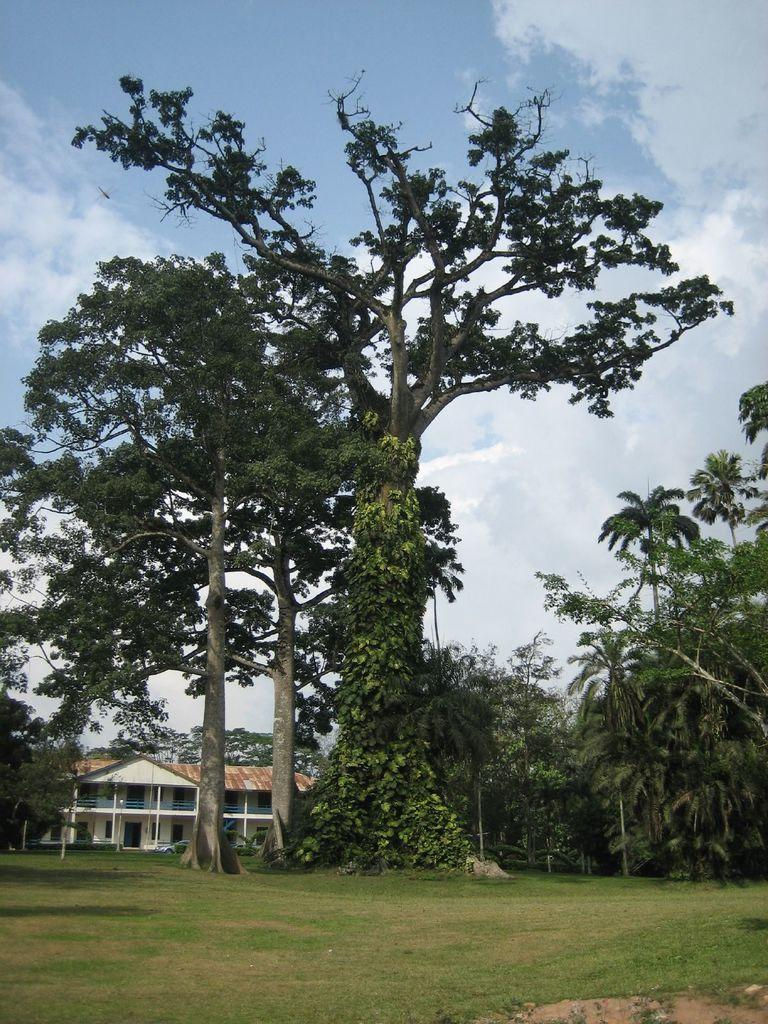What type of structure is present in the image? There is a building in the image. What feature can be observed on the building? The building has windows. What type of vegetation is present in the image? There are trees in the image. How would you describe the sky in the image? The sky is cloudy and pale blue. What type of ground surface is visible in the image? There is grass visible in the image. What color are the trousers worn by the giraffe in the image? There is no giraffe or trousers present in the image. What type of crayon is being used to draw on the building in the image? There is no crayon or drawing on the building in the image. 